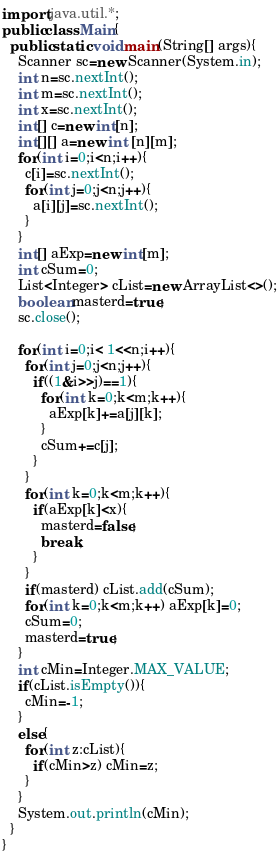<code> <loc_0><loc_0><loc_500><loc_500><_Java_>import java.util.*;
public class Main{
  public static void main(String[] args){
    Scanner sc=new Scanner(System.in);
    int n=sc.nextInt();
    int m=sc.nextInt();
    int x=sc.nextInt();
    int[] c=new int[n]; 
    int[][] a=new int [n][m]; 
    for(int i=0;i<n;i++){
      c[i]=sc.nextInt();
      for(int j=0;j<n;j++){
        a[i][j]=sc.nextInt();
      }
    }
    int[] aExp=new int[m];
    int cSum=0;
    List<Integer> cList=new ArrayList<>();
    boolean masterd=true;
    sc.close();
    
    for(int i=0;i< 1<<n;i++){
      for(int j=0;j<n;j++){
        if((1&i>>j)==1){
          for(int k=0;k<m;k++){
            aExp[k]+=a[j][k];
          }
          cSum+=c[j];
        }
      }
      for(int k=0;k<m;k++){
        if(aExp[k]<x){
          masterd=false;
          break;
        }
      }
      if(masterd) cList.add(cSum);
      for(int k=0;k<m;k++) aExp[k]=0;
      cSum=0;
      masterd=true;
    }
    int cMin=Integer.MAX_VALUE;
    if(cList.isEmpty()){
      cMin=-1;
    }
    else{
      for(int z:cList){
        if(cMin>z) cMin=z;
      }
    }
    System.out.println(cMin);
  }
}</code> 